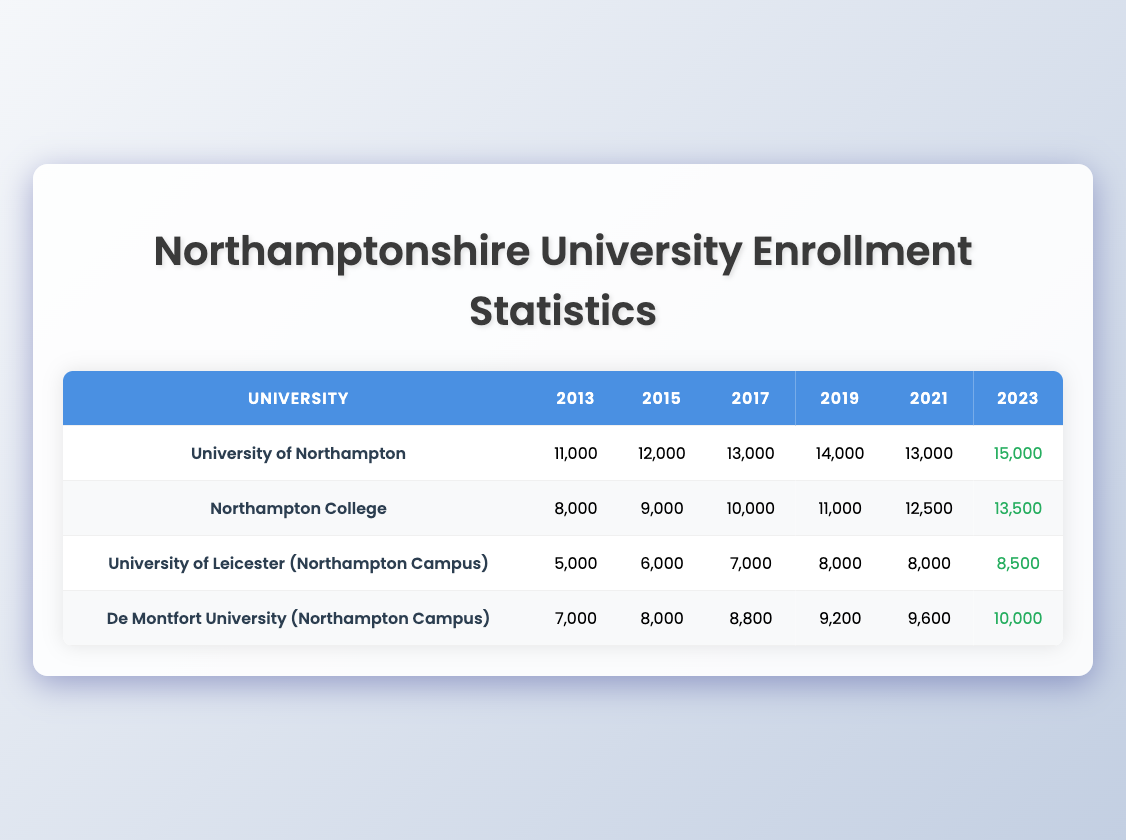What was the enrollment of the University of Northampton in 2023? Looking at the 2023 column for the University of Northampton, the enrollment is listed as 15,000.
Answer: 15,000 Which university had the highest enrollment in 2018? In the 2018 column of the table, the University of Northampton shows the highest enrollment with 13,500, compared to other universities.
Answer: University of Northampton What is the difference in enrollment between Northampton College in 2013 and in 2023? The enrollment for Northampton College in 2013 is 8,000, and in 2023 it is 13,500. The difference is 13,500 - 8,000 = 5,500.
Answer: 5,500 Which university had the lowest enrollment in 2013? The table shows that the University of Leicester (Northampton Campus) had the lowest enrollment in 2013 with 5,000.
Answer: University of Leicester (Northampton Campus) What was the total enrollment for all universities in Northamptonshire in 2021? To find the total enrollment in 2021, add the values: 13,000 (University of Northampton) + 12,500 (Northampton College) + 8,000 (University of Leicester) + 9,600 (De Montfort University) = 43,100.
Answer: 43,100 Did De Montfort University have an increase in enrollment from 2019 to 2023? Comparing the enrollment, De Montfort University had 9,200 in 2019 and increased to 10,000 in 2023, indicating an increase.
Answer: Yes What was the average enrollment across all universities in 2022? The enrollments in 2022 were: 14,500 (University of Northampton), 13,000 (Northampton College), 8,200 (University of Leicester), and 9,700 (De Montfort University). The average is (14,500 + 13,000 + 8,200 + 9,700)/4 = 11,850.
Answer: 11,850 Which university had a decrease in enrollment between 2019 and 2020? Looking at the data, the University of Northampton had a decrease from 14,000 in 2019 to 12,500 in 2020. Thus, it experienced a decrease in enrollment.
Answer: University of Northampton How many more students enrolled at Northampton College in 2023 compared to 2015? Northampton College had an enrollment of 9,000 in 2015 and 13,500 in 2023. The increase is 13,500 - 9,000 = 4,500.
Answer: 4,500 What is the total enrollment for the University of Leicester (Northampton Campus) from 2013 to 2023? The total enrollment from 2013 to 2023 is the sum of all the years: 5,000 + 6,000 + 7,000 + 8,000 + 7,000 + 7,500 + 8,000 + 8,200 + 8,500 = 58,200.
Answer: 58,200 